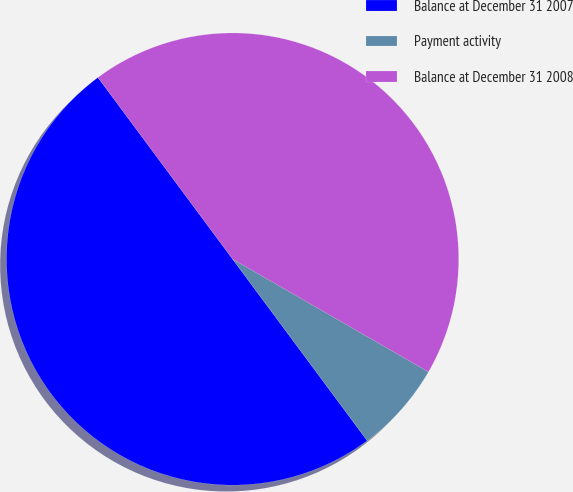Convert chart to OTSL. <chart><loc_0><loc_0><loc_500><loc_500><pie_chart><fcel>Balance at December 31 2007<fcel>Payment activity<fcel>Balance at December 31 2008<nl><fcel>50.0%<fcel>6.53%<fcel>43.47%<nl></chart> 